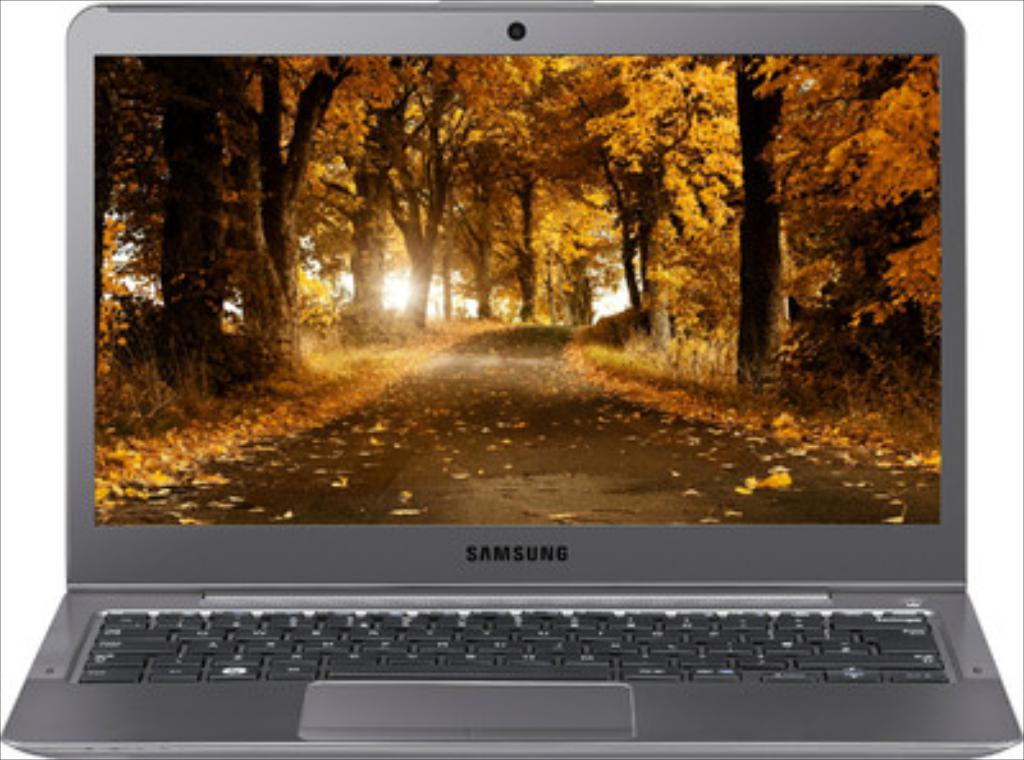<image>
Offer a succinct explanation of the picture presented. A black Samsung laptop displaying an autumn image with many colorful leaves. 